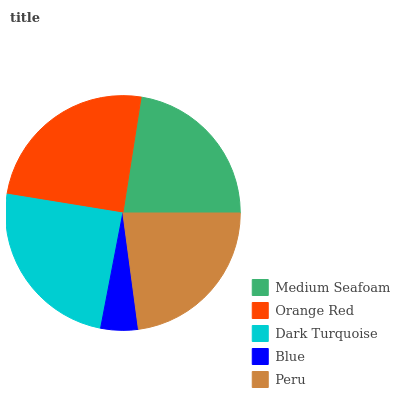Is Blue the minimum?
Answer yes or no. Yes. Is Orange Red the maximum?
Answer yes or no. Yes. Is Dark Turquoise the minimum?
Answer yes or no. No. Is Dark Turquoise the maximum?
Answer yes or no. No. Is Orange Red greater than Dark Turquoise?
Answer yes or no. Yes. Is Dark Turquoise less than Orange Red?
Answer yes or no. Yes. Is Dark Turquoise greater than Orange Red?
Answer yes or no. No. Is Orange Red less than Dark Turquoise?
Answer yes or no. No. Is Peru the high median?
Answer yes or no. Yes. Is Peru the low median?
Answer yes or no. Yes. Is Orange Red the high median?
Answer yes or no. No. Is Medium Seafoam the low median?
Answer yes or no. No. 